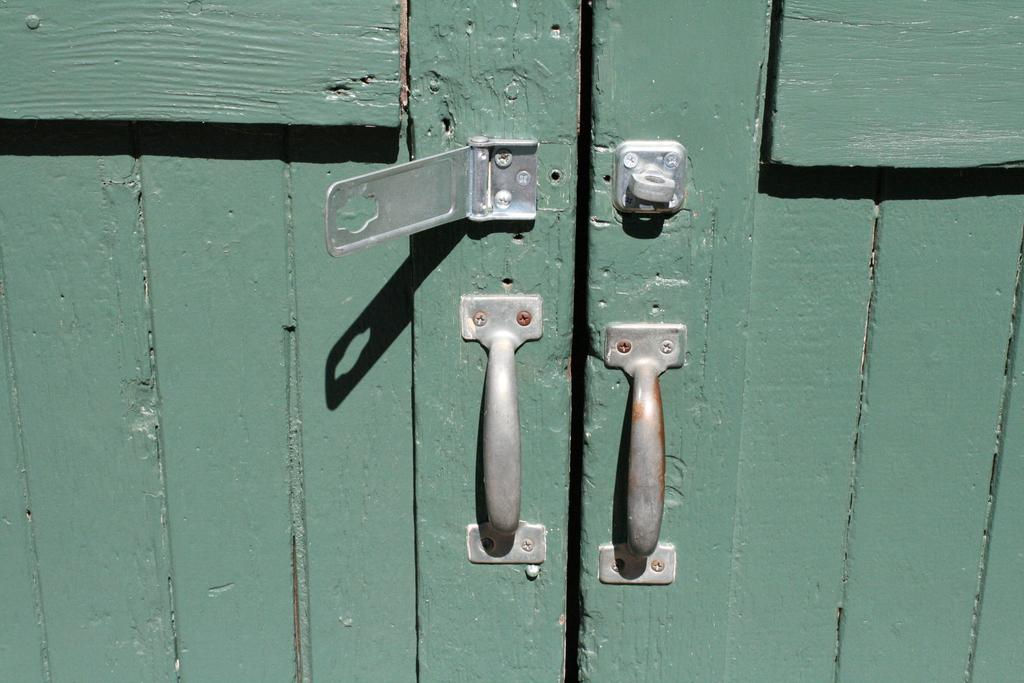What feature can be seen on the door in the image? There are handles on a door in the image. What additional feature is present on the door? There is a hook on the door in the image. What type of baseball equipment can be seen hanging from the hook on the door in the image? There is no baseball equipment present in the image; the hook is empty. 